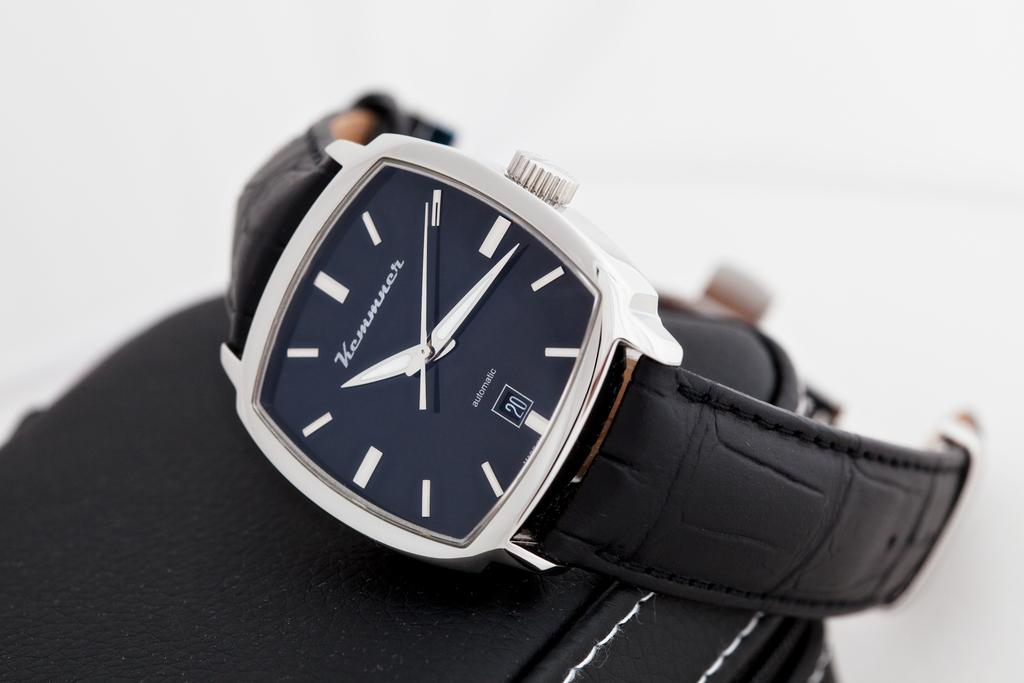<image>
Share a concise interpretation of the image provided. A watch with a leather band by Kemmner 